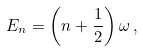<formula> <loc_0><loc_0><loc_500><loc_500>E _ { n } = \left ( n + \frac { 1 } { 2 } \right ) \omega \, ,</formula> 